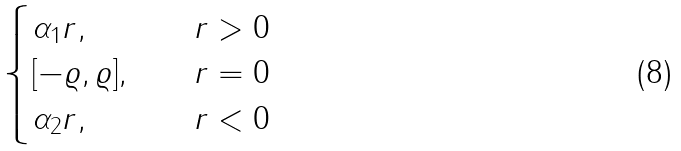Convert formula to latex. <formula><loc_0><loc_0><loc_500><loc_500>\begin{cases} \alpha _ { 1 } r , & \quad r > 0 \\ [ - \varrho , \varrho ] , & \quad r = 0 \\ \alpha _ { 2 } r , & \quad r < 0 \end{cases}</formula> 